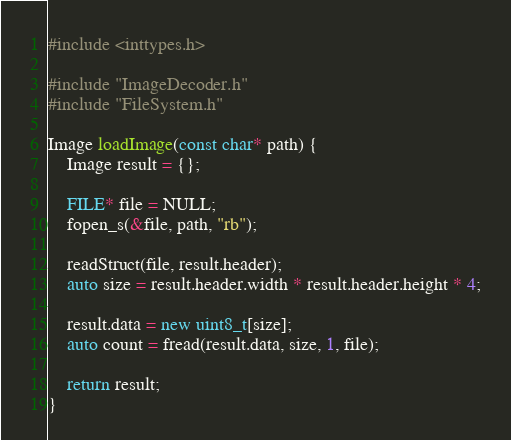Convert code to text. <code><loc_0><loc_0><loc_500><loc_500><_C++_>#include <inttypes.h>

#include "ImageDecoder.h"
#include "FileSystem.h"

Image loadImage(const char* path) {
    Image result = {};

    FILE* file = NULL;
    fopen_s(&file, path, "rb");

    readStruct(file, result.header);
    auto size = result.header.width * result.header.height * 4;

    result.data = new uint8_t[size];
    auto count = fread(result.data, size, 1, file);

    return result;
}
</code> 